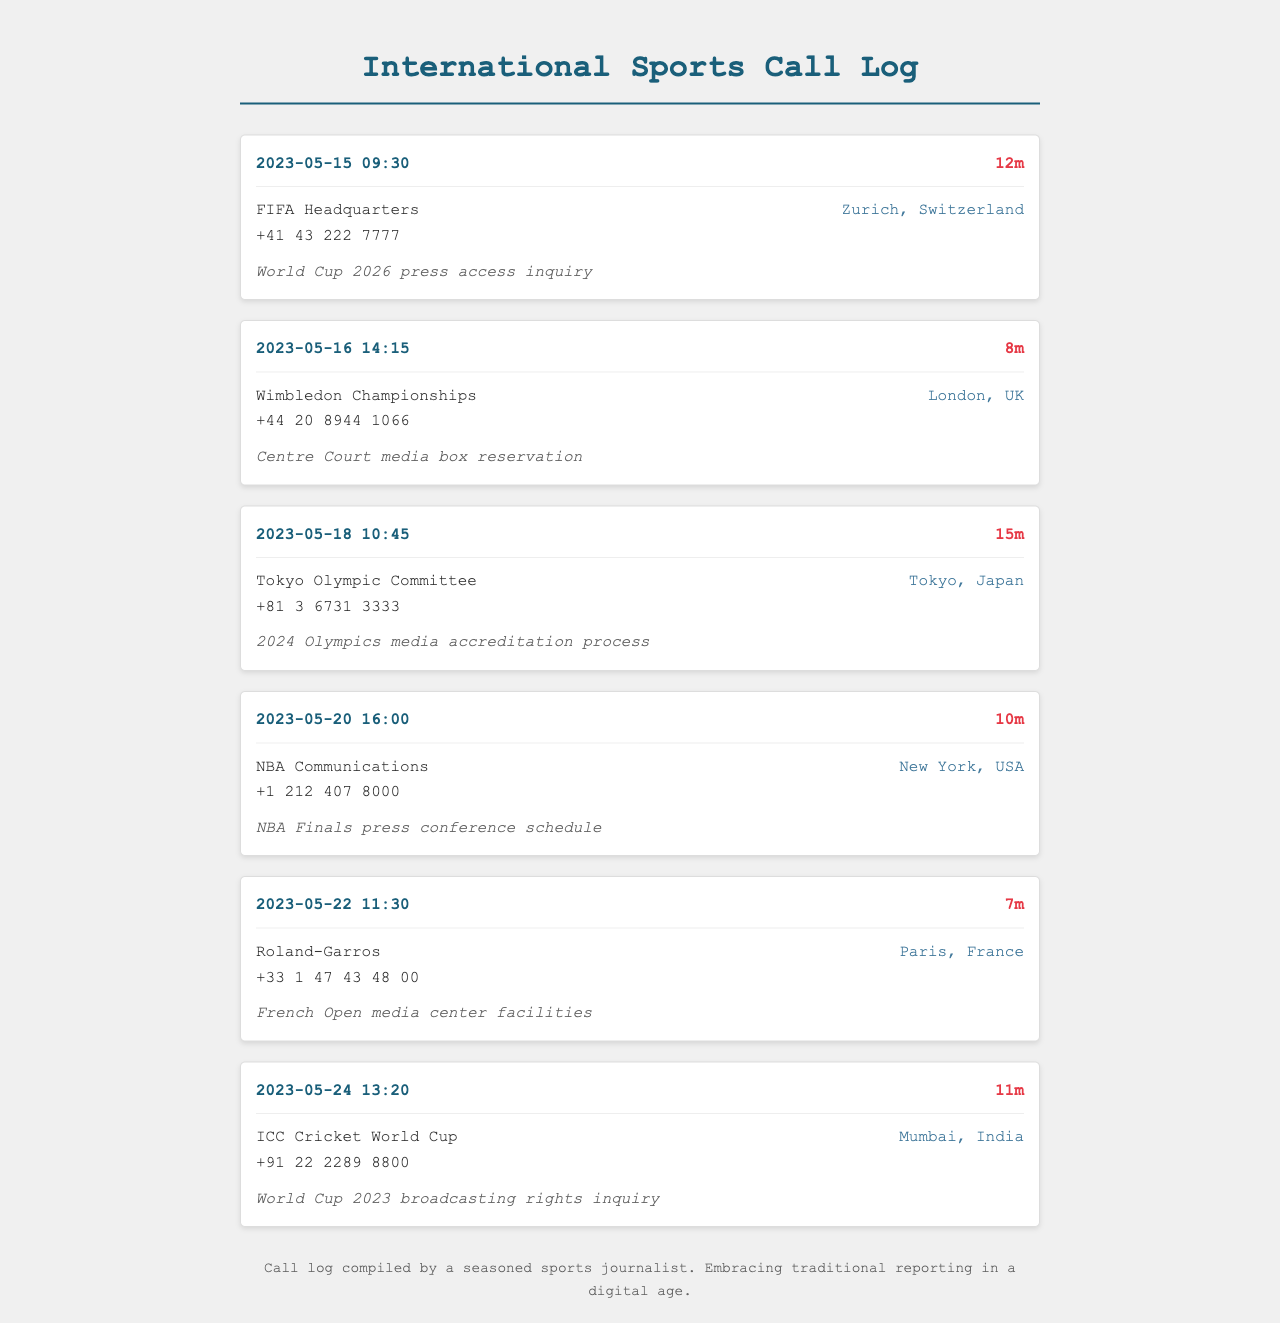What is the duration of the call to FIFA Headquarters? The duration of the call to FIFA Headquarters is mentioned under the call header.
Answer: 12m Who was contacted for the Wimbledon Championships coverage? The name of the organization contacted for Wimbledon Championships is listed in the call details.
Answer: Wimbledon Championships What is the purpose of the call made on May 18th? The purpose of the call is specified in the call-purpose section for May 18th.
Answer: 2024 Olympics media accreditation process What is the location of the ICC Cricket World Cup? The location of the ICC Cricket World Cup is provided in the call details section of that call.
Answer: Mumbai, India How many minutes long was the call to NBA Communications? The call duration is provided in minutes in the call header.
Answer: 10m Which event requires a media box reservation on May 16th? The event needing a media box reservation is mentioned in the call purpose for that date.
Answer: Wimbledon Championships What time did the call to Roland-Garros take place? The time of the call is included in the timestamp of the call header for Roland-Garros.
Answer: 11:30 How many calls are related to Olympic events? The log shows the calls related to Olympic events, counting those specifically mentioned in the document.
Answer: 2 Who is the likely audience of this call log? The audience is inferred from the purpose of the calls throughout the document.
Answer: Sports journalists 